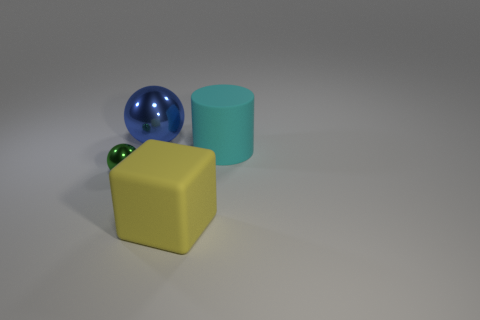Can you describe the shapes and colors of the objects present? Certainly! There are three objects in the image. One is a green cylinder, another is a yellow cube, and the third is a blue sphere.  Is there any indication of the light source in the image? Yes, the objects cast shadows towards the right, suggesting that the light source is coming from the left side of the frame. 